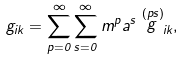Convert formula to latex. <formula><loc_0><loc_0><loc_500><loc_500>g _ { i k } = \sum _ { p = 0 } ^ { \infty } \sum _ { s = 0 } ^ { \infty } m ^ { p } a ^ { s } \stackrel { ( p s ) } { g } _ { i k } ,</formula> 